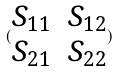<formula> <loc_0><loc_0><loc_500><loc_500>( \begin{matrix} S _ { 1 1 } & S _ { 1 2 } \\ S _ { 2 1 } & S _ { 2 2 } \end{matrix} )</formula> 